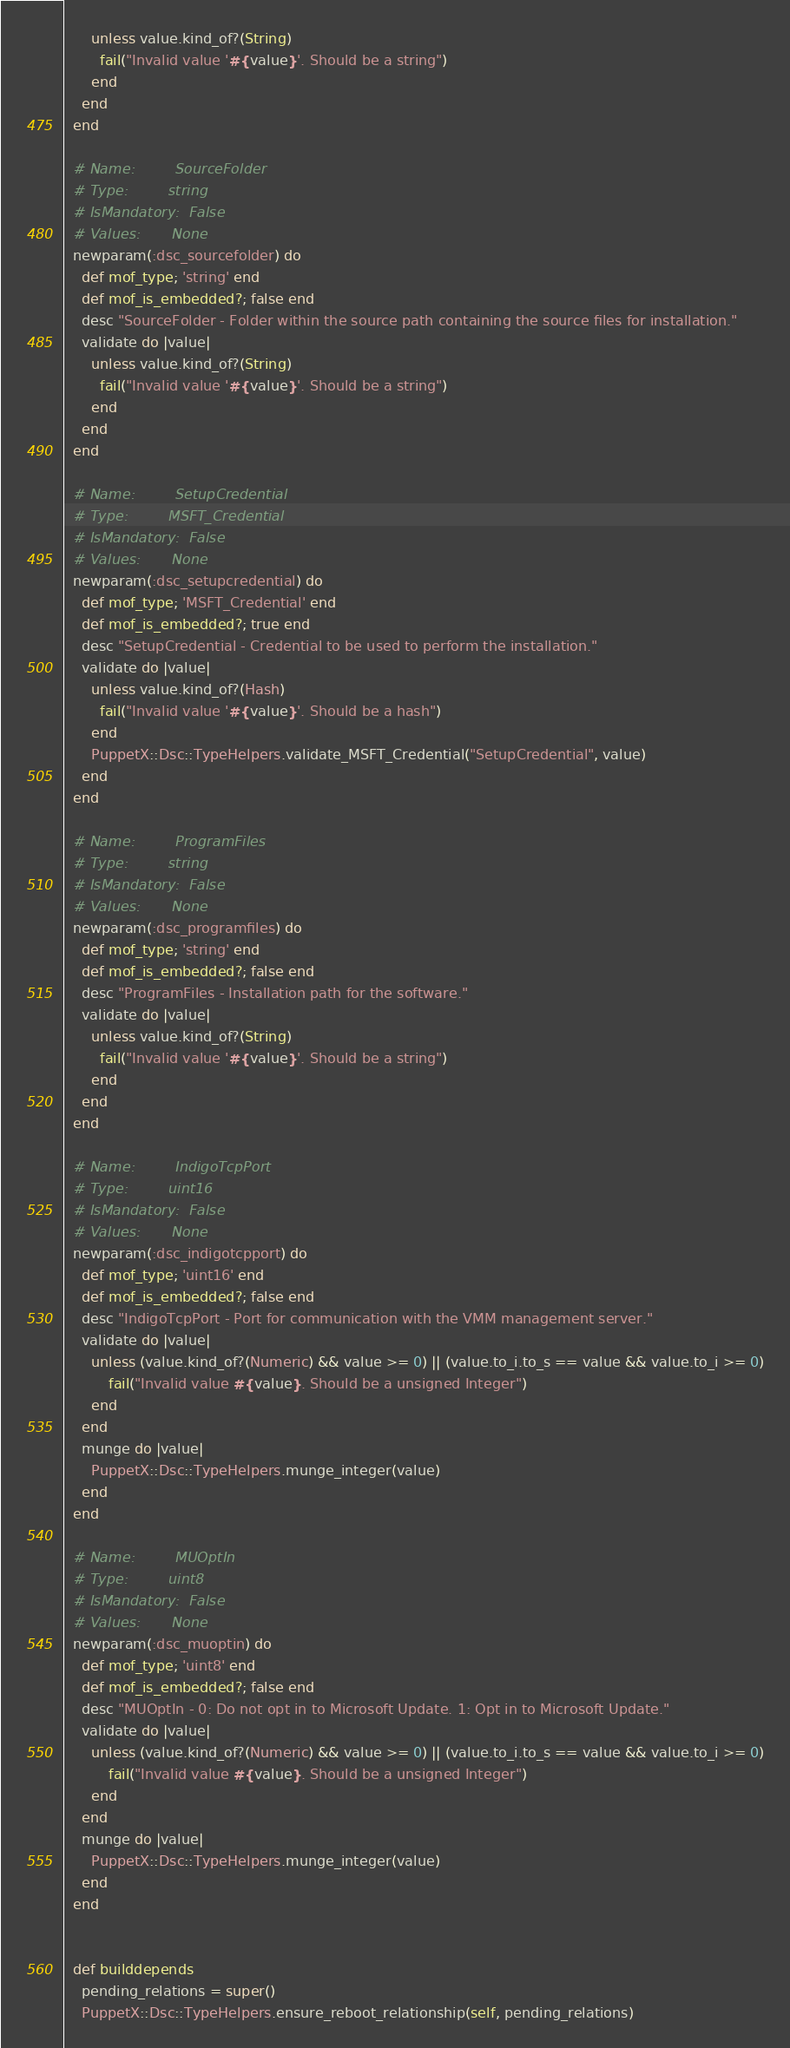Convert code to text. <code><loc_0><loc_0><loc_500><loc_500><_Ruby_>      unless value.kind_of?(String)
        fail("Invalid value '#{value}'. Should be a string")
      end
    end
  end

  # Name:         SourceFolder
  # Type:         string
  # IsMandatory:  False
  # Values:       None
  newparam(:dsc_sourcefolder) do
    def mof_type; 'string' end
    def mof_is_embedded?; false end
    desc "SourceFolder - Folder within the source path containing the source files for installation."
    validate do |value|
      unless value.kind_of?(String)
        fail("Invalid value '#{value}'. Should be a string")
      end
    end
  end

  # Name:         SetupCredential
  # Type:         MSFT_Credential
  # IsMandatory:  False
  # Values:       None
  newparam(:dsc_setupcredential) do
    def mof_type; 'MSFT_Credential' end
    def mof_is_embedded?; true end
    desc "SetupCredential - Credential to be used to perform the installation."
    validate do |value|
      unless value.kind_of?(Hash)
        fail("Invalid value '#{value}'. Should be a hash")
      end
      PuppetX::Dsc::TypeHelpers.validate_MSFT_Credential("SetupCredential", value)
    end
  end

  # Name:         ProgramFiles
  # Type:         string
  # IsMandatory:  False
  # Values:       None
  newparam(:dsc_programfiles) do
    def mof_type; 'string' end
    def mof_is_embedded?; false end
    desc "ProgramFiles - Installation path for the software."
    validate do |value|
      unless value.kind_of?(String)
        fail("Invalid value '#{value}'. Should be a string")
      end
    end
  end

  # Name:         IndigoTcpPort
  # Type:         uint16
  # IsMandatory:  False
  # Values:       None
  newparam(:dsc_indigotcpport) do
    def mof_type; 'uint16' end
    def mof_is_embedded?; false end
    desc "IndigoTcpPort - Port for communication with the VMM management server."
    validate do |value|
      unless (value.kind_of?(Numeric) && value >= 0) || (value.to_i.to_s == value && value.to_i >= 0)
          fail("Invalid value #{value}. Should be a unsigned Integer")
      end
    end
    munge do |value|
      PuppetX::Dsc::TypeHelpers.munge_integer(value)
    end
  end

  # Name:         MUOptIn
  # Type:         uint8
  # IsMandatory:  False
  # Values:       None
  newparam(:dsc_muoptin) do
    def mof_type; 'uint8' end
    def mof_is_embedded?; false end
    desc "MUOptIn - 0: Do not opt in to Microsoft Update. 1: Opt in to Microsoft Update."
    validate do |value|
      unless (value.kind_of?(Numeric) && value >= 0) || (value.to_i.to_s == value && value.to_i >= 0)
          fail("Invalid value #{value}. Should be a unsigned Integer")
      end
    end
    munge do |value|
      PuppetX::Dsc::TypeHelpers.munge_integer(value)
    end
  end


  def builddepends
    pending_relations = super()
    PuppetX::Dsc::TypeHelpers.ensure_reboot_relationship(self, pending_relations)</code> 